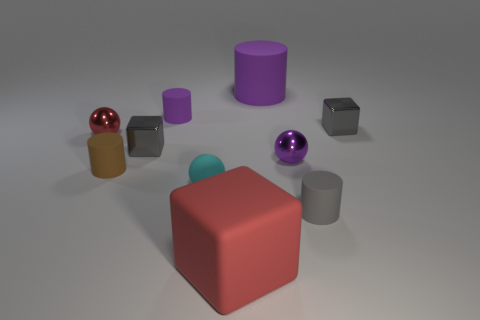Subtract 1 cylinders. How many cylinders are left? 3 Subtract all cylinders. How many objects are left? 6 Subtract all small red metallic things. Subtract all matte cubes. How many objects are left? 8 Add 9 brown objects. How many brown objects are left? 10 Add 2 green metallic cubes. How many green metallic cubes exist? 2 Subtract 0 blue spheres. How many objects are left? 10 